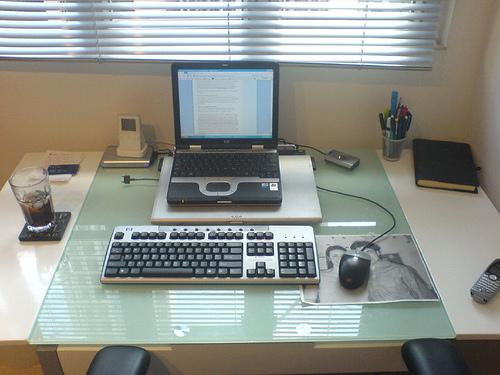Is someone using the laptop at this moment?
Concise answer only. No. Where is the mp3 player?
Quick response, please. Desk. What is being used as a mouse pad?
Answer briefly. Picture. 